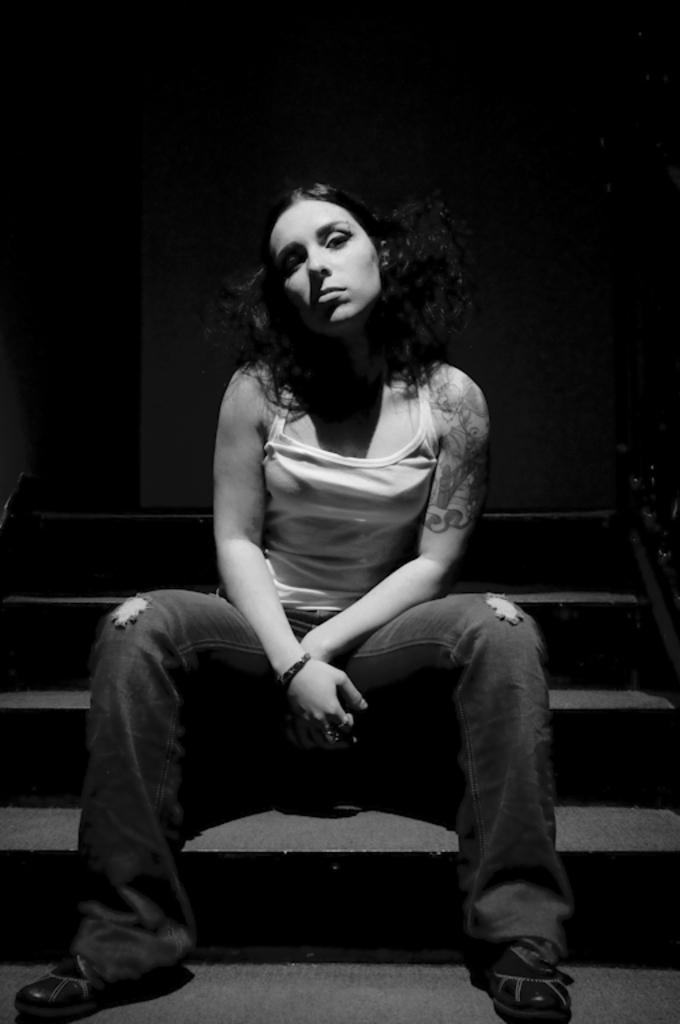Who is the main subject in the image? There is a lady in the image. What is the lady doing in the image? The lady is sitting on the stairs. What can be seen in the background of the image? There is a wall in the background of the image. What type of necklace is the lady wearing in the image? There is no necklace visible in the image; the lady is not wearing any jewelry. 